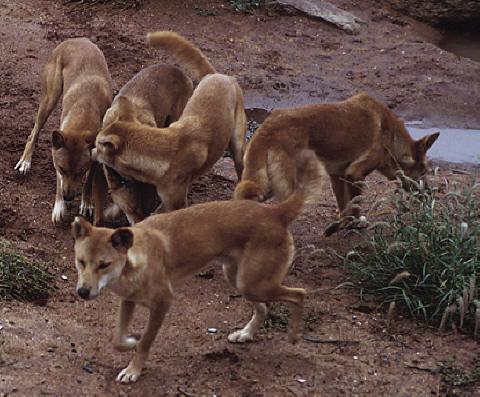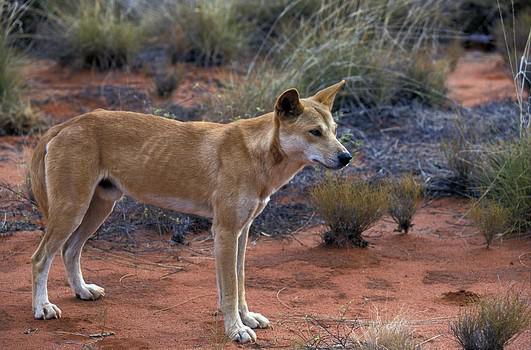The first image is the image on the left, the second image is the image on the right. Examine the images to the left and right. Is the description "An image includes a dog sleeping on the ground." accurate? Answer yes or no. No. The first image is the image on the left, the second image is the image on the right. Evaluate the accuracy of this statement regarding the images: "A single dog stands on a rock in the image on the right.". Is it true? Answer yes or no. No. 